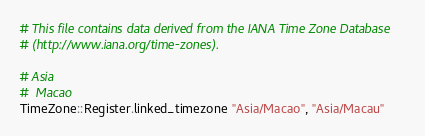Convert code to text. <code><loc_0><loc_0><loc_500><loc_500><_Crystal_># This file contains data derived from the IANA Time Zone Database
# (http://www.iana.org/time-zones).

# Asia
#  Macao
TimeZone::Register.linked_timezone "Asia/Macao", "Asia/Macau"
</code> 